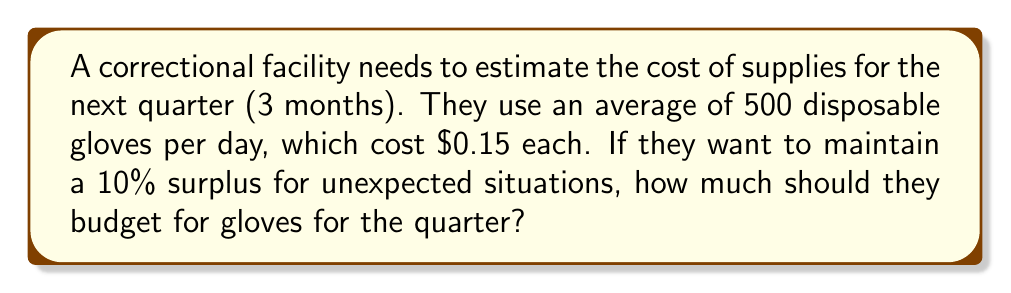Help me with this question. Let's break this down step-by-step:

1) First, calculate the number of days in a quarter:
   3 months × 30 days/month = 90 days

2) Calculate the number of gloves needed for 90 days:
   500 gloves/day × 90 days = 45,000 gloves

3) Add 10% surplus:
   45,000 + (10% of 45,000) = 45,000 + 4,500 = 49,500 gloves

4) Calculate the cost:
   49,500 gloves × $0.15/glove = $7,425

Therefore, the correctional facility should budget $7,425 for gloves for the quarter.

To write this as an equation:

$$\text{Budget} = \text{Days} \times \text{Gloves per day} \times (1 + \text{Surplus %}) \times \text{Cost per glove}$$

$$\text{Budget} = 90 \times 500 \times (1 + 0.10) \times $0.15 = $7,425$$
Answer: $7,425 